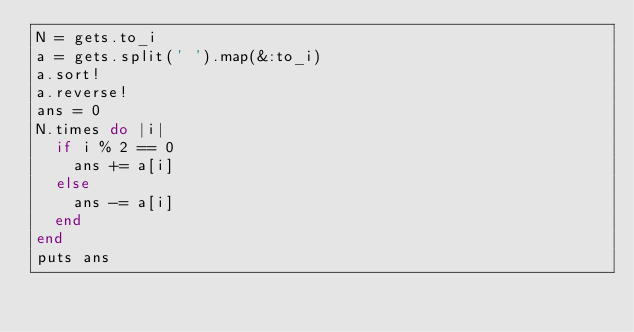<code> <loc_0><loc_0><loc_500><loc_500><_Ruby_>N = gets.to_i
a = gets.split(' ').map(&:to_i)
a.sort!
a.reverse!
ans = 0
N.times do |i|
  if i % 2 == 0
    ans += a[i]
  else
    ans -= a[i]
  end
end
puts ans</code> 